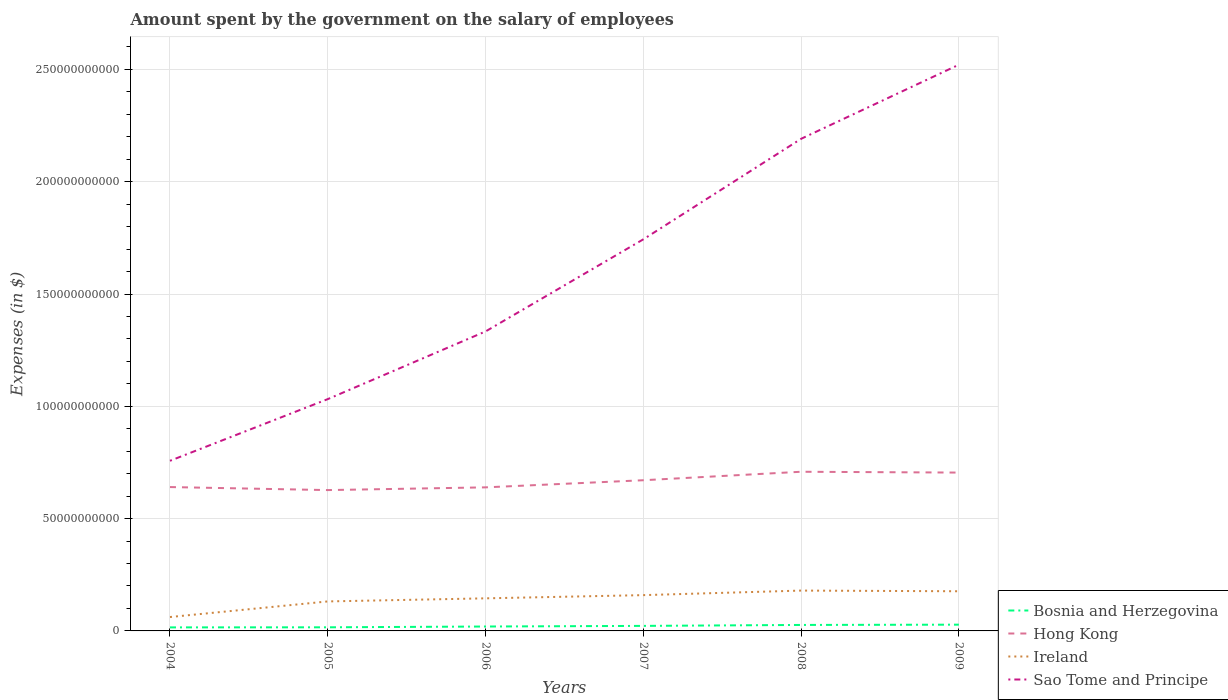How many different coloured lines are there?
Provide a short and direct response. 4. Does the line corresponding to Sao Tome and Principe intersect with the line corresponding to Hong Kong?
Give a very brief answer. No. Across all years, what is the maximum amount spent on the salary of employees by the government in Hong Kong?
Offer a terse response. 6.27e+1. In which year was the amount spent on the salary of employees by the government in Ireland maximum?
Provide a short and direct response. 2004. What is the total amount spent on the salary of employees by the government in Sao Tome and Principe in the graph?
Provide a short and direct response. -4.10e+1. What is the difference between the highest and the second highest amount spent on the salary of employees by the government in Hong Kong?
Your answer should be very brief. 8.16e+09. How many lines are there?
Keep it short and to the point. 4. Does the graph contain grids?
Keep it short and to the point. Yes. How many legend labels are there?
Provide a succinct answer. 4. How are the legend labels stacked?
Offer a very short reply. Vertical. What is the title of the graph?
Offer a very short reply. Amount spent by the government on the salary of employees. What is the label or title of the X-axis?
Make the answer very short. Years. What is the label or title of the Y-axis?
Offer a very short reply. Expenses (in $). What is the Expenses (in $) in Bosnia and Herzegovina in 2004?
Your answer should be very brief. 1.57e+09. What is the Expenses (in $) of Hong Kong in 2004?
Make the answer very short. 6.41e+1. What is the Expenses (in $) in Ireland in 2004?
Offer a very short reply. 6.18e+09. What is the Expenses (in $) in Sao Tome and Principe in 2004?
Make the answer very short. 7.57e+1. What is the Expenses (in $) of Bosnia and Herzegovina in 2005?
Give a very brief answer. 1.61e+09. What is the Expenses (in $) in Hong Kong in 2005?
Your response must be concise. 6.27e+1. What is the Expenses (in $) in Ireland in 2005?
Give a very brief answer. 1.31e+1. What is the Expenses (in $) of Sao Tome and Principe in 2005?
Offer a terse response. 1.03e+11. What is the Expenses (in $) of Bosnia and Herzegovina in 2006?
Provide a short and direct response. 1.96e+09. What is the Expenses (in $) in Hong Kong in 2006?
Your answer should be very brief. 6.39e+1. What is the Expenses (in $) in Ireland in 2006?
Provide a succinct answer. 1.45e+1. What is the Expenses (in $) of Sao Tome and Principe in 2006?
Your answer should be very brief. 1.33e+11. What is the Expenses (in $) of Bosnia and Herzegovina in 2007?
Offer a very short reply. 2.24e+09. What is the Expenses (in $) in Hong Kong in 2007?
Offer a terse response. 6.71e+1. What is the Expenses (in $) of Ireland in 2007?
Keep it short and to the point. 1.59e+1. What is the Expenses (in $) of Sao Tome and Principe in 2007?
Provide a succinct answer. 1.74e+11. What is the Expenses (in $) of Bosnia and Herzegovina in 2008?
Your answer should be compact. 2.66e+09. What is the Expenses (in $) in Hong Kong in 2008?
Keep it short and to the point. 7.09e+1. What is the Expenses (in $) of Ireland in 2008?
Your response must be concise. 1.80e+1. What is the Expenses (in $) in Sao Tome and Principe in 2008?
Give a very brief answer. 2.19e+11. What is the Expenses (in $) of Bosnia and Herzegovina in 2009?
Your answer should be compact. 2.79e+09. What is the Expenses (in $) of Hong Kong in 2009?
Make the answer very short. 7.05e+1. What is the Expenses (in $) of Ireland in 2009?
Provide a short and direct response. 1.77e+1. What is the Expenses (in $) in Sao Tome and Principe in 2009?
Ensure brevity in your answer.  2.52e+11. Across all years, what is the maximum Expenses (in $) in Bosnia and Herzegovina?
Keep it short and to the point. 2.79e+09. Across all years, what is the maximum Expenses (in $) in Hong Kong?
Provide a succinct answer. 7.09e+1. Across all years, what is the maximum Expenses (in $) of Ireland?
Offer a very short reply. 1.80e+1. Across all years, what is the maximum Expenses (in $) of Sao Tome and Principe?
Provide a short and direct response. 2.52e+11. Across all years, what is the minimum Expenses (in $) of Bosnia and Herzegovina?
Your answer should be very brief. 1.57e+09. Across all years, what is the minimum Expenses (in $) of Hong Kong?
Offer a terse response. 6.27e+1. Across all years, what is the minimum Expenses (in $) in Ireland?
Offer a very short reply. 6.18e+09. Across all years, what is the minimum Expenses (in $) of Sao Tome and Principe?
Your response must be concise. 7.57e+1. What is the total Expenses (in $) in Bosnia and Herzegovina in the graph?
Your response must be concise. 1.28e+1. What is the total Expenses (in $) in Hong Kong in the graph?
Offer a very short reply. 3.99e+11. What is the total Expenses (in $) of Ireland in the graph?
Provide a succinct answer. 8.54e+1. What is the total Expenses (in $) of Sao Tome and Principe in the graph?
Ensure brevity in your answer.  9.58e+11. What is the difference between the Expenses (in $) of Bosnia and Herzegovina in 2004 and that in 2005?
Ensure brevity in your answer.  -3.61e+07. What is the difference between the Expenses (in $) in Hong Kong in 2004 and that in 2005?
Keep it short and to the point. 1.35e+09. What is the difference between the Expenses (in $) of Ireland in 2004 and that in 2005?
Keep it short and to the point. -6.95e+09. What is the difference between the Expenses (in $) in Sao Tome and Principe in 2004 and that in 2005?
Offer a very short reply. -2.75e+1. What is the difference between the Expenses (in $) in Bosnia and Herzegovina in 2004 and that in 2006?
Make the answer very short. -3.90e+08. What is the difference between the Expenses (in $) in Hong Kong in 2004 and that in 2006?
Offer a terse response. 1.32e+08. What is the difference between the Expenses (in $) in Ireland in 2004 and that in 2006?
Offer a very short reply. -8.32e+09. What is the difference between the Expenses (in $) of Sao Tome and Principe in 2004 and that in 2006?
Make the answer very short. -5.76e+1. What is the difference between the Expenses (in $) of Bosnia and Herzegovina in 2004 and that in 2007?
Ensure brevity in your answer.  -6.67e+08. What is the difference between the Expenses (in $) in Hong Kong in 2004 and that in 2007?
Offer a very short reply. -3.04e+09. What is the difference between the Expenses (in $) in Ireland in 2004 and that in 2007?
Your answer should be very brief. -9.75e+09. What is the difference between the Expenses (in $) in Sao Tome and Principe in 2004 and that in 2007?
Provide a short and direct response. -9.86e+1. What is the difference between the Expenses (in $) of Bosnia and Herzegovina in 2004 and that in 2008?
Offer a terse response. -1.09e+09. What is the difference between the Expenses (in $) in Hong Kong in 2004 and that in 2008?
Your response must be concise. -6.82e+09. What is the difference between the Expenses (in $) of Ireland in 2004 and that in 2008?
Offer a terse response. -1.18e+1. What is the difference between the Expenses (in $) of Sao Tome and Principe in 2004 and that in 2008?
Your answer should be compact. -1.43e+11. What is the difference between the Expenses (in $) in Bosnia and Herzegovina in 2004 and that in 2009?
Ensure brevity in your answer.  -1.22e+09. What is the difference between the Expenses (in $) in Hong Kong in 2004 and that in 2009?
Provide a succinct answer. -6.44e+09. What is the difference between the Expenses (in $) of Ireland in 2004 and that in 2009?
Your response must be concise. -1.15e+1. What is the difference between the Expenses (in $) of Sao Tome and Principe in 2004 and that in 2009?
Provide a short and direct response. -1.76e+11. What is the difference between the Expenses (in $) in Bosnia and Herzegovina in 2005 and that in 2006?
Make the answer very short. -3.54e+08. What is the difference between the Expenses (in $) of Hong Kong in 2005 and that in 2006?
Offer a very short reply. -1.22e+09. What is the difference between the Expenses (in $) in Ireland in 2005 and that in 2006?
Provide a succinct answer. -1.38e+09. What is the difference between the Expenses (in $) in Sao Tome and Principe in 2005 and that in 2006?
Keep it short and to the point. -3.01e+1. What is the difference between the Expenses (in $) of Bosnia and Herzegovina in 2005 and that in 2007?
Your answer should be very brief. -6.31e+08. What is the difference between the Expenses (in $) of Hong Kong in 2005 and that in 2007?
Make the answer very short. -4.39e+09. What is the difference between the Expenses (in $) in Ireland in 2005 and that in 2007?
Your response must be concise. -2.80e+09. What is the difference between the Expenses (in $) in Sao Tome and Principe in 2005 and that in 2007?
Make the answer very short. -7.11e+1. What is the difference between the Expenses (in $) of Bosnia and Herzegovina in 2005 and that in 2008?
Your answer should be very brief. -1.05e+09. What is the difference between the Expenses (in $) of Hong Kong in 2005 and that in 2008?
Offer a terse response. -8.16e+09. What is the difference between the Expenses (in $) in Ireland in 2005 and that in 2008?
Give a very brief answer. -4.83e+09. What is the difference between the Expenses (in $) in Sao Tome and Principe in 2005 and that in 2008?
Offer a terse response. -1.16e+11. What is the difference between the Expenses (in $) of Bosnia and Herzegovina in 2005 and that in 2009?
Make the answer very short. -1.18e+09. What is the difference between the Expenses (in $) of Hong Kong in 2005 and that in 2009?
Your answer should be very brief. -7.79e+09. What is the difference between the Expenses (in $) in Ireland in 2005 and that in 2009?
Keep it short and to the point. -4.53e+09. What is the difference between the Expenses (in $) in Sao Tome and Principe in 2005 and that in 2009?
Offer a terse response. -1.49e+11. What is the difference between the Expenses (in $) of Bosnia and Herzegovina in 2006 and that in 2007?
Offer a terse response. -2.78e+08. What is the difference between the Expenses (in $) of Hong Kong in 2006 and that in 2007?
Make the answer very short. -3.17e+09. What is the difference between the Expenses (in $) in Ireland in 2006 and that in 2007?
Give a very brief answer. -1.43e+09. What is the difference between the Expenses (in $) of Sao Tome and Principe in 2006 and that in 2007?
Give a very brief answer. -4.10e+1. What is the difference between the Expenses (in $) of Bosnia and Herzegovina in 2006 and that in 2008?
Your response must be concise. -7.01e+08. What is the difference between the Expenses (in $) in Hong Kong in 2006 and that in 2008?
Ensure brevity in your answer.  -6.95e+09. What is the difference between the Expenses (in $) of Ireland in 2006 and that in 2008?
Make the answer very short. -3.45e+09. What is the difference between the Expenses (in $) of Sao Tome and Principe in 2006 and that in 2008?
Give a very brief answer. -8.58e+1. What is the difference between the Expenses (in $) in Bosnia and Herzegovina in 2006 and that in 2009?
Ensure brevity in your answer.  -8.26e+08. What is the difference between the Expenses (in $) of Hong Kong in 2006 and that in 2009?
Offer a very short reply. -6.58e+09. What is the difference between the Expenses (in $) in Ireland in 2006 and that in 2009?
Your answer should be very brief. -3.15e+09. What is the difference between the Expenses (in $) in Sao Tome and Principe in 2006 and that in 2009?
Provide a short and direct response. -1.19e+11. What is the difference between the Expenses (in $) in Bosnia and Herzegovina in 2007 and that in 2008?
Your response must be concise. -4.23e+08. What is the difference between the Expenses (in $) in Hong Kong in 2007 and that in 2008?
Provide a succinct answer. -3.78e+09. What is the difference between the Expenses (in $) of Ireland in 2007 and that in 2008?
Offer a very short reply. -2.02e+09. What is the difference between the Expenses (in $) of Sao Tome and Principe in 2007 and that in 2008?
Offer a terse response. -4.48e+1. What is the difference between the Expenses (in $) of Bosnia and Herzegovina in 2007 and that in 2009?
Offer a terse response. -5.48e+08. What is the difference between the Expenses (in $) of Hong Kong in 2007 and that in 2009?
Your answer should be compact. -3.40e+09. What is the difference between the Expenses (in $) in Ireland in 2007 and that in 2009?
Your answer should be very brief. -1.73e+09. What is the difference between the Expenses (in $) in Sao Tome and Principe in 2007 and that in 2009?
Offer a very short reply. -7.77e+1. What is the difference between the Expenses (in $) of Bosnia and Herzegovina in 2008 and that in 2009?
Your answer should be very brief. -1.25e+08. What is the difference between the Expenses (in $) in Hong Kong in 2008 and that in 2009?
Offer a very short reply. 3.72e+08. What is the difference between the Expenses (in $) of Ireland in 2008 and that in 2009?
Keep it short and to the point. 2.99e+08. What is the difference between the Expenses (in $) in Sao Tome and Principe in 2008 and that in 2009?
Ensure brevity in your answer.  -3.30e+1. What is the difference between the Expenses (in $) of Bosnia and Herzegovina in 2004 and the Expenses (in $) of Hong Kong in 2005?
Make the answer very short. -6.11e+1. What is the difference between the Expenses (in $) of Bosnia and Herzegovina in 2004 and the Expenses (in $) of Ireland in 2005?
Your response must be concise. -1.16e+1. What is the difference between the Expenses (in $) of Bosnia and Herzegovina in 2004 and the Expenses (in $) of Sao Tome and Principe in 2005?
Your answer should be very brief. -1.02e+11. What is the difference between the Expenses (in $) of Hong Kong in 2004 and the Expenses (in $) of Ireland in 2005?
Your answer should be compact. 5.09e+1. What is the difference between the Expenses (in $) of Hong Kong in 2004 and the Expenses (in $) of Sao Tome and Principe in 2005?
Your answer should be very brief. -3.92e+1. What is the difference between the Expenses (in $) in Ireland in 2004 and the Expenses (in $) in Sao Tome and Principe in 2005?
Your response must be concise. -9.70e+1. What is the difference between the Expenses (in $) in Bosnia and Herzegovina in 2004 and the Expenses (in $) in Hong Kong in 2006?
Your answer should be very brief. -6.23e+1. What is the difference between the Expenses (in $) in Bosnia and Herzegovina in 2004 and the Expenses (in $) in Ireland in 2006?
Ensure brevity in your answer.  -1.29e+1. What is the difference between the Expenses (in $) of Bosnia and Herzegovina in 2004 and the Expenses (in $) of Sao Tome and Principe in 2006?
Provide a succinct answer. -1.32e+11. What is the difference between the Expenses (in $) in Hong Kong in 2004 and the Expenses (in $) in Ireland in 2006?
Your answer should be compact. 4.95e+1. What is the difference between the Expenses (in $) of Hong Kong in 2004 and the Expenses (in $) of Sao Tome and Principe in 2006?
Make the answer very short. -6.93e+1. What is the difference between the Expenses (in $) of Ireland in 2004 and the Expenses (in $) of Sao Tome and Principe in 2006?
Offer a terse response. -1.27e+11. What is the difference between the Expenses (in $) in Bosnia and Herzegovina in 2004 and the Expenses (in $) in Hong Kong in 2007?
Offer a very short reply. -6.55e+1. What is the difference between the Expenses (in $) of Bosnia and Herzegovina in 2004 and the Expenses (in $) of Ireland in 2007?
Keep it short and to the point. -1.44e+1. What is the difference between the Expenses (in $) of Bosnia and Herzegovina in 2004 and the Expenses (in $) of Sao Tome and Principe in 2007?
Your answer should be compact. -1.73e+11. What is the difference between the Expenses (in $) in Hong Kong in 2004 and the Expenses (in $) in Ireland in 2007?
Your answer should be very brief. 4.81e+1. What is the difference between the Expenses (in $) in Hong Kong in 2004 and the Expenses (in $) in Sao Tome and Principe in 2007?
Your answer should be compact. -1.10e+11. What is the difference between the Expenses (in $) of Ireland in 2004 and the Expenses (in $) of Sao Tome and Principe in 2007?
Provide a succinct answer. -1.68e+11. What is the difference between the Expenses (in $) in Bosnia and Herzegovina in 2004 and the Expenses (in $) in Hong Kong in 2008?
Give a very brief answer. -6.93e+1. What is the difference between the Expenses (in $) in Bosnia and Herzegovina in 2004 and the Expenses (in $) in Ireland in 2008?
Make the answer very short. -1.64e+1. What is the difference between the Expenses (in $) of Bosnia and Herzegovina in 2004 and the Expenses (in $) of Sao Tome and Principe in 2008?
Keep it short and to the point. -2.18e+11. What is the difference between the Expenses (in $) of Hong Kong in 2004 and the Expenses (in $) of Ireland in 2008?
Give a very brief answer. 4.61e+1. What is the difference between the Expenses (in $) of Hong Kong in 2004 and the Expenses (in $) of Sao Tome and Principe in 2008?
Keep it short and to the point. -1.55e+11. What is the difference between the Expenses (in $) of Ireland in 2004 and the Expenses (in $) of Sao Tome and Principe in 2008?
Ensure brevity in your answer.  -2.13e+11. What is the difference between the Expenses (in $) in Bosnia and Herzegovina in 2004 and the Expenses (in $) in Hong Kong in 2009?
Offer a terse response. -6.89e+1. What is the difference between the Expenses (in $) of Bosnia and Herzegovina in 2004 and the Expenses (in $) of Ireland in 2009?
Ensure brevity in your answer.  -1.61e+1. What is the difference between the Expenses (in $) in Bosnia and Herzegovina in 2004 and the Expenses (in $) in Sao Tome and Principe in 2009?
Your answer should be compact. -2.51e+11. What is the difference between the Expenses (in $) of Hong Kong in 2004 and the Expenses (in $) of Ireland in 2009?
Provide a short and direct response. 4.64e+1. What is the difference between the Expenses (in $) in Hong Kong in 2004 and the Expenses (in $) in Sao Tome and Principe in 2009?
Your answer should be very brief. -1.88e+11. What is the difference between the Expenses (in $) of Ireland in 2004 and the Expenses (in $) of Sao Tome and Principe in 2009?
Provide a succinct answer. -2.46e+11. What is the difference between the Expenses (in $) in Bosnia and Herzegovina in 2005 and the Expenses (in $) in Hong Kong in 2006?
Provide a succinct answer. -6.23e+1. What is the difference between the Expenses (in $) in Bosnia and Herzegovina in 2005 and the Expenses (in $) in Ireland in 2006?
Your response must be concise. -1.29e+1. What is the difference between the Expenses (in $) of Bosnia and Herzegovina in 2005 and the Expenses (in $) of Sao Tome and Principe in 2006?
Ensure brevity in your answer.  -1.32e+11. What is the difference between the Expenses (in $) of Hong Kong in 2005 and the Expenses (in $) of Ireland in 2006?
Provide a short and direct response. 4.82e+1. What is the difference between the Expenses (in $) in Hong Kong in 2005 and the Expenses (in $) in Sao Tome and Principe in 2006?
Give a very brief answer. -7.06e+1. What is the difference between the Expenses (in $) of Ireland in 2005 and the Expenses (in $) of Sao Tome and Principe in 2006?
Provide a succinct answer. -1.20e+11. What is the difference between the Expenses (in $) in Bosnia and Herzegovina in 2005 and the Expenses (in $) in Hong Kong in 2007?
Ensure brevity in your answer.  -6.55e+1. What is the difference between the Expenses (in $) in Bosnia and Herzegovina in 2005 and the Expenses (in $) in Ireland in 2007?
Offer a terse response. -1.43e+1. What is the difference between the Expenses (in $) of Bosnia and Herzegovina in 2005 and the Expenses (in $) of Sao Tome and Principe in 2007?
Your answer should be compact. -1.73e+11. What is the difference between the Expenses (in $) in Hong Kong in 2005 and the Expenses (in $) in Ireland in 2007?
Provide a short and direct response. 4.68e+1. What is the difference between the Expenses (in $) in Hong Kong in 2005 and the Expenses (in $) in Sao Tome and Principe in 2007?
Offer a terse response. -1.12e+11. What is the difference between the Expenses (in $) of Ireland in 2005 and the Expenses (in $) of Sao Tome and Principe in 2007?
Your response must be concise. -1.61e+11. What is the difference between the Expenses (in $) of Bosnia and Herzegovina in 2005 and the Expenses (in $) of Hong Kong in 2008?
Provide a succinct answer. -6.93e+1. What is the difference between the Expenses (in $) of Bosnia and Herzegovina in 2005 and the Expenses (in $) of Ireland in 2008?
Offer a terse response. -1.64e+1. What is the difference between the Expenses (in $) in Bosnia and Herzegovina in 2005 and the Expenses (in $) in Sao Tome and Principe in 2008?
Offer a terse response. -2.17e+11. What is the difference between the Expenses (in $) in Hong Kong in 2005 and the Expenses (in $) in Ireland in 2008?
Your answer should be very brief. 4.47e+1. What is the difference between the Expenses (in $) of Hong Kong in 2005 and the Expenses (in $) of Sao Tome and Principe in 2008?
Your answer should be very brief. -1.56e+11. What is the difference between the Expenses (in $) of Ireland in 2005 and the Expenses (in $) of Sao Tome and Principe in 2008?
Your answer should be very brief. -2.06e+11. What is the difference between the Expenses (in $) in Bosnia and Herzegovina in 2005 and the Expenses (in $) in Hong Kong in 2009?
Your answer should be very brief. -6.89e+1. What is the difference between the Expenses (in $) of Bosnia and Herzegovina in 2005 and the Expenses (in $) of Ireland in 2009?
Offer a terse response. -1.61e+1. What is the difference between the Expenses (in $) in Bosnia and Herzegovina in 2005 and the Expenses (in $) in Sao Tome and Principe in 2009?
Offer a very short reply. -2.50e+11. What is the difference between the Expenses (in $) of Hong Kong in 2005 and the Expenses (in $) of Ireland in 2009?
Make the answer very short. 4.50e+1. What is the difference between the Expenses (in $) of Hong Kong in 2005 and the Expenses (in $) of Sao Tome and Principe in 2009?
Offer a terse response. -1.89e+11. What is the difference between the Expenses (in $) in Ireland in 2005 and the Expenses (in $) in Sao Tome and Principe in 2009?
Ensure brevity in your answer.  -2.39e+11. What is the difference between the Expenses (in $) of Bosnia and Herzegovina in 2006 and the Expenses (in $) of Hong Kong in 2007?
Keep it short and to the point. -6.51e+1. What is the difference between the Expenses (in $) in Bosnia and Herzegovina in 2006 and the Expenses (in $) in Ireland in 2007?
Offer a terse response. -1.40e+1. What is the difference between the Expenses (in $) in Bosnia and Herzegovina in 2006 and the Expenses (in $) in Sao Tome and Principe in 2007?
Your answer should be compact. -1.72e+11. What is the difference between the Expenses (in $) in Hong Kong in 2006 and the Expenses (in $) in Ireland in 2007?
Your answer should be compact. 4.80e+1. What is the difference between the Expenses (in $) in Hong Kong in 2006 and the Expenses (in $) in Sao Tome and Principe in 2007?
Provide a short and direct response. -1.10e+11. What is the difference between the Expenses (in $) in Ireland in 2006 and the Expenses (in $) in Sao Tome and Principe in 2007?
Your answer should be compact. -1.60e+11. What is the difference between the Expenses (in $) in Bosnia and Herzegovina in 2006 and the Expenses (in $) in Hong Kong in 2008?
Make the answer very short. -6.89e+1. What is the difference between the Expenses (in $) of Bosnia and Herzegovina in 2006 and the Expenses (in $) of Ireland in 2008?
Provide a short and direct response. -1.60e+1. What is the difference between the Expenses (in $) in Bosnia and Herzegovina in 2006 and the Expenses (in $) in Sao Tome and Principe in 2008?
Provide a short and direct response. -2.17e+11. What is the difference between the Expenses (in $) in Hong Kong in 2006 and the Expenses (in $) in Ireland in 2008?
Your answer should be compact. 4.60e+1. What is the difference between the Expenses (in $) in Hong Kong in 2006 and the Expenses (in $) in Sao Tome and Principe in 2008?
Keep it short and to the point. -1.55e+11. What is the difference between the Expenses (in $) in Ireland in 2006 and the Expenses (in $) in Sao Tome and Principe in 2008?
Provide a succinct answer. -2.05e+11. What is the difference between the Expenses (in $) in Bosnia and Herzegovina in 2006 and the Expenses (in $) in Hong Kong in 2009?
Ensure brevity in your answer.  -6.85e+1. What is the difference between the Expenses (in $) of Bosnia and Herzegovina in 2006 and the Expenses (in $) of Ireland in 2009?
Ensure brevity in your answer.  -1.57e+1. What is the difference between the Expenses (in $) in Bosnia and Herzegovina in 2006 and the Expenses (in $) in Sao Tome and Principe in 2009?
Give a very brief answer. -2.50e+11. What is the difference between the Expenses (in $) in Hong Kong in 2006 and the Expenses (in $) in Ireland in 2009?
Provide a succinct answer. 4.63e+1. What is the difference between the Expenses (in $) in Hong Kong in 2006 and the Expenses (in $) in Sao Tome and Principe in 2009?
Make the answer very short. -1.88e+11. What is the difference between the Expenses (in $) of Ireland in 2006 and the Expenses (in $) of Sao Tome and Principe in 2009?
Offer a terse response. -2.38e+11. What is the difference between the Expenses (in $) in Bosnia and Herzegovina in 2007 and the Expenses (in $) in Hong Kong in 2008?
Offer a very short reply. -6.86e+1. What is the difference between the Expenses (in $) of Bosnia and Herzegovina in 2007 and the Expenses (in $) of Ireland in 2008?
Your response must be concise. -1.57e+1. What is the difference between the Expenses (in $) in Bosnia and Herzegovina in 2007 and the Expenses (in $) in Sao Tome and Principe in 2008?
Keep it short and to the point. -2.17e+11. What is the difference between the Expenses (in $) of Hong Kong in 2007 and the Expenses (in $) of Ireland in 2008?
Keep it short and to the point. 4.91e+1. What is the difference between the Expenses (in $) in Hong Kong in 2007 and the Expenses (in $) in Sao Tome and Principe in 2008?
Your answer should be very brief. -1.52e+11. What is the difference between the Expenses (in $) in Ireland in 2007 and the Expenses (in $) in Sao Tome and Principe in 2008?
Make the answer very short. -2.03e+11. What is the difference between the Expenses (in $) of Bosnia and Herzegovina in 2007 and the Expenses (in $) of Hong Kong in 2009?
Provide a succinct answer. -6.83e+1. What is the difference between the Expenses (in $) in Bosnia and Herzegovina in 2007 and the Expenses (in $) in Ireland in 2009?
Offer a very short reply. -1.54e+1. What is the difference between the Expenses (in $) of Bosnia and Herzegovina in 2007 and the Expenses (in $) of Sao Tome and Principe in 2009?
Provide a succinct answer. -2.50e+11. What is the difference between the Expenses (in $) of Hong Kong in 2007 and the Expenses (in $) of Ireland in 2009?
Your answer should be compact. 4.94e+1. What is the difference between the Expenses (in $) of Hong Kong in 2007 and the Expenses (in $) of Sao Tome and Principe in 2009?
Make the answer very short. -1.85e+11. What is the difference between the Expenses (in $) of Ireland in 2007 and the Expenses (in $) of Sao Tome and Principe in 2009?
Your answer should be compact. -2.36e+11. What is the difference between the Expenses (in $) of Bosnia and Herzegovina in 2008 and the Expenses (in $) of Hong Kong in 2009?
Provide a short and direct response. -6.78e+1. What is the difference between the Expenses (in $) of Bosnia and Herzegovina in 2008 and the Expenses (in $) of Ireland in 2009?
Give a very brief answer. -1.50e+1. What is the difference between the Expenses (in $) in Bosnia and Herzegovina in 2008 and the Expenses (in $) in Sao Tome and Principe in 2009?
Provide a short and direct response. -2.49e+11. What is the difference between the Expenses (in $) in Hong Kong in 2008 and the Expenses (in $) in Ireland in 2009?
Give a very brief answer. 5.32e+1. What is the difference between the Expenses (in $) of Hong Kong in 2008 and the Expenses (in $) of Sao Tome and Principe in 2009?
Your answer should be compact. -1.81e+11. What is the difference between the Expenses (in $) in Ireland in 2008 and the Expenses (in $) in Sao Tome and Principe in 2009?
Your answer should be compact. -2.34e+11. What is the average Expenses (in $) of Bosnia and Herzegovina per year?
Make the answer very short. 2.14e+09. What is the average Expenses (in $) of Hong Kong per year?
Ensure brevity in your answer.  6.65e+1. What is the average Expenses (in $) in Ireland per year?
Provide a succinct answer. 1.42e+1. What is the average Expenses (in $) of Sao Tome and Principe per year?
Make the answer very short. 1.60e+11. In the year 2004, what is the difference between the Expenses (in $) in Bosnia and Herzegovina and Expenses (in $) in Hong Kong?
Offer a very short reply. -6.25e+1. In the year 2004, what is the difference between the Expenses (in $) of Bosnia and Herzegovina and Expenses (in $) of Ireland?
Provide a short and direct response. -4.61e+09. In the year 2004, what is the difference between the Expenses (in $) in Bosnia and Herzegovina and Expenses (in $) in Sao Tome and Principe?
Provide a succinct answer. -7.42e+1. In the year 2004, what is the difference between the Expenses (in $) of Hong Kong and Expenses (in $) of Ireland?
Provide a succinct answer. 5.79e+1. In the year 2004, what is the difference between the Expenses (in $) of Hong Kong and Expenses (in $) of Sao Tome and Principe?
Offer a terse response. -1.17e+1. In the year 2004, what is the difference between the Expenses (in $) of Ireland and Expenses (in $) of Sao Tome and Principe?
Provide a short and direct response. -6.96e+1. In the year 2005, what is the difference between the Expenses (in $) of Bosnia and Herzegovina and Expenses (in $) of Hong Kong?
Your answer should be compact. -6.11e+1. In the year 2005, what is the difference between the Expenses (in $) of Bosnia and Herzegovina and Expenses (in $) of Ireland?
Your answer should be very brief. -1.15e+1. In the year 2005, what is the difference between the Expenses (in $) of Bosnia and Herzegovina and Expenses (in $) of Sao Tome and Principe?
Offer a very short reply. -1.02e+11. In the year 2005, what is the difference between the Expenses (in $) of Hong Kong and Expenses (in $) of Ireland?
Offer a terse response. 4.96e+1. In the year 2005, what is the difference between the Expenses (in $) of Hong Kong and Expenses (in $) of Sao Tome and Principe?
Offer a very short reply. -4.05e+1. In the year 2005, what is the difference between the Expenses (in $) in Ireland and Expenses (in $) in Sao Tome and Principe?
Give a very brief answer. -9.01e+1. In the year 2006, what is the difference between the Expenses (in $) in Bosnia and Herzegovina and Expenses (in $) in Hong Kong?
Offer a terse response. -6.20e+1. In the year 2006, what is the difference between the Expenses (in $) in Bosnia and Herzegovina and Expenses (in $) in Ireland?
Give a very brief answer. -1.25e+1. In the year 2006, what is the difference between the Expenses (in $) in Bosnia and Herzegovina and Expenses (in $) in Sao Tome and Principe?
Make the answer very short. -1.31e+11. In the year 2006, what is the difference between the Expenses (in $) in Hong Kong and Expenses (in $) in Ireland?
Provide a succinct answer. 4.94e+1. In the year 2006, what is the difference between the Expenses (in $) of Hong Kong and Expenses (in $) of Sao Tome and Principe?
Your answer should be compact. -6.94e+1. In the year 2006, what is the difference between the Expenses (in $) in Ireland and Expenses (in $) in Sao Tome and Principe?
Give a very brief answer. -1.19e+11. In the year 2007, what is the difference between the Expenses (in $) in Bosnia and Herzegovina and Expenses (in $) in Hong Kong?
Give a very brief answer. -6.48e+1. In the year 2007, what is the difference between the Expenses (in $) in Bosnia and Herzegovina and Expenses (in $) in Ireland?
Give a very brief answer. -1.37e+1. In the year 2007, what is the difference between the Expenses (in $) of Bosnia and Herzegovina and Expenses (in $) of Sao Tome and Principe?
Your answer should be compact. -1.72e+11. In the year 2007, what is the difference between the Expenses (in $) of Hong Kong and Expenses (in $) of Ireland?
Keep it short and to the point. 5.12e+1. In the year 2007, what is the difference between the Expenses (in $) in Hong Kong and Expenses (in $) in Sao Tome and Principe?
Your response must be concise. -1.07e+11. In the year 2007, what is the difference between the Expenses (in $) of Ireland and Expenses (in $) of Sao Tome and Principe?
Offer a very short reply. -1.58e+11. In the year 2008, what is the difference between the Expenses (in $) of Bosnia and Herzegovina and Expenses (in $) of Hong Kong?
Your response must be concise. -6.82e+1. In the year 2008, what is the difference between the Expenses (in $) in Bosnia and Herzegovina and Expenses (in $) in Ireland?
Offer a very short reply. -1.53e+1. In the year 2008, what is the difference between the Expenses (in $) of Bosnia and Herzegovina and Expenses (in $) of Sao Tome and Principe?
Provide a succinct answer. -2.16e+11. In the year 2008, what is the difference between the Expenses (in $) in Hong Kong and Expenses (in $) in Ireland?
Make the answer very short. 5.29e+1. In the year 2008, what is the difference between the Expenses (in $) of Hong Kong and Expenses (in $) of Sao Tome and Principe?
Your response must be concise. -1.48e+11. In the year 2008, what is the difference between the Expenses (in $) of Ireland and Expenses (in $) of Sao Tome and Principe?
Your answer should be very brief. -2.01e+11. In the year 2009, what is the difference between the Expenses (in $) in Bosnia and Herzegovina and Expenses (in $) in Hong Kong?
Provide a short and direct response. -6.77e+1. In the year 2009, what is the difference between the Expenses (in $) in Bosnia and Herzegovina and Expenses (in $) in Ireland?
Keep it short and to the point. -1.49e+1. In the year 2009, what is the difference between the Expenses (in $) of Bosnia and Herzegovina and Expenses (in $) of Sao Tome and Principe?
Make the answer very short. -2.49e+11. In the year 2009, what is the difference between the Expenses (in $) in Hong Kong and Expenses (in $) in Ireland?
Give a very brief answer. 5.28e+1. In the year 2009, what is the difference between the Expenses (in $) of Hong Kong and Expenses (in $) of Sao Tome and Principe?
Make the answer very short. -1.82e+11. In the year 2009, what is the difference between the Expenses (in $) in Ireland and Expenses (in $) in Sao Tome and Principe?
Your response must be concise. -2.34e+11. What is the ratio of the Expenses (in $) in Bosnia and Herzegovina in 2004 to that in 2005?
Your response must be concise. 0.98. What is the ratio of the Expenses (in $) of Hong Kong in 2004 to that in 2005?
Make the answer very short. 1.02. What is the ratio of the Expenses (in $) of Ireland in 2004 to that in 2005?
Ensure brevity in your answer.  0.47. What is the ratio of the Expenses (in $) of Sao Tome and Principe in 2004 to that in 2005?
Offer a very short reply. 0.73. What is the ratio of the Expenses (in $) of Bosnia and Herzegovina in 2004 to that in 2006?
Offer a terse response. 0.8. What is the ratio of the Expenses (in $) of Ireland in 2004 to that in 2006?
Your answer should be very brief. 0.43. What is the ratio of the Expenses (in $) in Sao Tome and Principe in 2004 to that in 2006?
Provide a succinct answer. 0.57. What is the ratio of the Expenses (in $) in Bosnia and Herzegovina in 2004 to that in 2007?
Offer a terse response. 0.7. What is the ratio of the Expenses (in $) of Hong Kong in 2004 to that in 2007?
Give a very brief answer. 0.95. What is the ratio of the Expenses (in $) of Ireland in 2004 to that in 2007?
Your answer should be very brief. 0.39. What is the ratio of the Expenses (in $) in Sao Tome and Principe in 2004 to that in 2007?
Your response must be concise. 0.43. What is the ratio of the Expenses (in $) of Bosnia and Herzegovina in 2004 to that in 2008?
Offer a terse response. 0.59. What is the ratio of the Expenses (in $) in Hong Kong in 2004 to that in 2008?
Ensure brevity in your answer.  0.9. What is the ratio of the Expenses (in $) of Ireland in 2004 to that in 2008?
Your response must be concise. 0.34. What is the ratio of the Expenses (in $) in Sao Tome and Principe in 2004 to that in 2008?
Ensure brevity in your answer.  0.35. What is the ratio of the Expenses (in $) of Bosnia and Herzegovina in 2004 to that in 2009?
Your response must be concise. 0.56. What is the ratio of the Expenses (in $) of Hong Kong in 2004 to that in 2009?
Ensure brevity in your answer.  0.91. What is the ratio of the Expenses (in $) of Ireland in 2004 to that in 2009?
Give a very brief answer. 0.35. What is the ratio of the Expenses (in $) in Sao Tome and Principe in 2004 to that in 2009?
Your answer should be compact. 0.3. What is the ratio of the Expenses (in $) of Bosnia and Herzegovina in 2005 to that in 2006?
Keep it short and to the point. 0.82. What is the ratio of the Expenses (in $) in Ireland in 2005 to that in 2006?
Offer a terse response. 0.91. What is the ratio of the Expenses (in $) of Sao Tome and Principe in 2005 to that in 2006?
Offer a terse response. 0.77. What is the ratio of the Expenses (in $) of Bosnia and Herzegovina in 2005 to that in 2007?
Offer a terse response. 0.72. What is the ratio of the Expenses (in $) of Hong Kong in 2005 to that in 2007?
Keep it short and to the point. 0.93. What is the ratio of the Expenses (in $) in Ireland in 2005 to that in 2007?
Make the answer very short. 0.82. What is the ratio of the Expenses (in $) in Sao Tome and Principe in 2005 to that in 2007?
Your answer should be compact. 0.59. What is the ratio of the Expenses (in $) in Bosnia and Herzegovina in 2005 to that in 2008?
Your answer should be very brief. 0.6. What is the ratio of the Expenses (in $) of Hong Kong in 2005 to that in 2008?
Keep it short and to the point. 0.88. What is the ratio of the Expenses (in $) in Ireland in 2005 to that in 2008?
Provide a succinct answer. 0.73. What is the ratio of the Expenses (in $) of Sao Tome and Principe in 2005 to that in 2008?
Your answer should be very brief. 0.47. What is the ratio of the Expenses (in $) of Bosnia and Herzegovina in 2005 to that in 2009?
Make the answer very short. 0.58. What is the ratio of the Expenses (in $) of Hong Kong in 2005 to that in 2009?
Provide a succinct answer. 0.89. What is the ratio of the Expenses (in $) of Ireland in 2005 to that in 2009?
Make the answer very short. 0.74. What is the ratio of the Expenses (in $) of Sao Tome and Principe in 2005 to that in 2009?
Offer a very short reply. 0.41. What is the ratio of the Expenses (in $) of Bosnia and Herzegovina in 2006 to that in 2007?
Offer a very short reply. 0.88. What is the ratio of the Expenses (in $) in Hong Kong in 2006 to that in 2007?
Your answer should be very brief. 0.95. What is the ratio of the Expenses (in $) of Ireland in 2006 to that in 2007?
Your answer should be compact. 0.91. What is the ratio of the Expenses (in $) of Sao Tome and Principe in 2006 to that in 2007?
Your answer should be very brief. 0.76. What is the ratio of the Expenses (in $) of Bosnia and Herzegovina in 2006 to that in 2008?
Make the answer very short. 0.74. What is the ratio of the Expenses (in $) of Hong Kong in 2006 to that in 2008?
Provide a short and direct response. 0.9. What is the ratio of the Expenses (in $) of Ireland in 2006 to that in 2008?
Make the answer very short. 0.81. What is the ratio of the Expenses (in $) in Sao Tome and Principe in 2006 to that in 2008?
Provide a succinct answer. 0.61. What is the ratio of the Expenses (in $) in Bosnia and Herzegovina in 2006 to that in 2009?
Provide a succinct answer. 0.7. What is the ratio of the Expenses (in $) of Hong Kong in 2006 to that in 2009?
Your answer should be compact. 0.91. What is the ratio of the Expenses (in $) in Ireland in 2006 to that in 2009?
Give a very brief answer. 0.82. What is the ratio of the Expenses (in $) of Sao Tome and Principe in 2006 to that in 2009?
Offer a very short reply. 0.53. What is the ratio of the Expenses (in $) in Bosnia and Herzegovina in 2007 to that in 2008?
Offer a terse response. 0.84. What is the ratio of the Expenses (in $) in Hong Kong in 2007 to that in 2008?
Your answer should be very brief. 0.95. What is the ratio of the Expenses (in $) in Ireland in 2007 to that in 2008?
Offer a terse response. 0.89. What is the ratio of the Expenses (in $) in Sao Tome and Principe in 2007 to that in 2008?
Offer a very short reply. 0.8. What is the ratio of the Expenses (in $) of Bosnia and Herzegovina in 2007 to that in 2009?
Your answer should be compact. 0.8. What is the ratio of the Expenses (in $) of Hong Kong in 2007 to that in 2009?
Provide a short and direct response. 0.95. What is the ratio of the Expenses (in $) of Ireland in 2007 to that in 2009?
Offer a very short reply. 0.9. What is the ratio of the Expenses (in $) of Sao Tome and Principe in 2007 to that in 2009?
Your response must be concise. 0.69. What is the ratio of the Expenses (in $) in Bosnia and Herzegovina in 2008 to that in 2009?
Your answer should be compact. 0.95. What is the ratio of the Expenses (in $) in Hong Kong in 2008 to that in 2009?
Keep it short and to the point. 1.01. What is the ratio of the Expenses (in $) in Ireland in 2008 to that in 2009?
Provide a succinct answer. 1.02. What is the ratio of the Expenses (in $) in Sao Tome and Principe in 2008 to that in 2009?
Make the answer very short. 0.87. What is the difference between the highest and the second highest Expenses (in $) in Bosnia and Herzegovina?
Keep it short and to the point. 1.25e+08. What is the difference between the highest and the second highest Expenses (in $) in Hong Kong?
Your response must be concise. 3.72e+08. What is the difference between the highest and the second highest Expenses (in $) in Ireland?
Make the answer very short. 2.99e+08. What is the difference between the highest and the second highest Expenses (in $) of Sao Tome and Principe?
Ensure brevity in your answer.  3.30e+1. What is the difference between the highest and the lowest Expenses (in $) in Bosnia and Herzegovina?
Your answer should be very brief. 1.22e+09. What is the difference between the highest and the lowest Expenses (in $) in Hong Kong?
Keep it short and to the point. 8.16e+09. What is the difference between the highest and the lowest Expenses (in $) in Ireland?
Keep it short and to the point. 1.18e+1. What is the difference between the highest and the lowest Expenses (in $) of Sao Tome and Principe?
Your answer should be compact. 1.76e+11. 